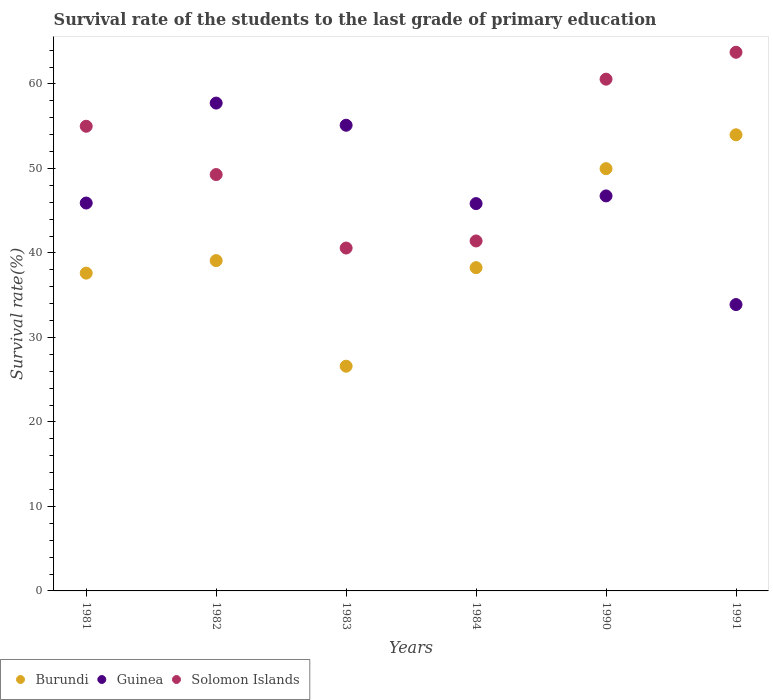Is the number of dotlines equal to the number of legend labels?
Give a very brief answer. Yes. What is the survival rate of the students in Guinea in 1982?
Keep it short and to the point. 57.73. Across all years, what is the maximum survival rate of the students in Burundi?
Offer a very short reply. 53.98. Across all years, what is the minimum survival rate of the students in Burundi?
Ensure brevity in your answer.  26.59. In which year was the survival rate of the students in Guinea minimum?
Offer a very short reply. 1991. What is the total survival rate of the students in Guinea in the graph?
Provide a short and direct response. 285.21. What is the difference between the survival rate of the students in Guinea in 1982 and that in 1991?
Your answer should be very brief. 23.84. What is the difference between the survival rate of the students in Solomon Islands in 1984 and the survival rate of the students in Burundi in 1982?
Your response must be concise. 2.32. What is the average survival rate of the students in Solomon Islands per year?
Your answer should be very brief. 51.76. In the year 1984, what is the difference between the survival rate of the students in Burundi and survival rate of the students in Solomon Islands?
Make the answer very short. -3.16. In how many years, is the survival rate of the students in Burundi greater than 26 %?
Provide a succinct answer. 6. What is the ratio of the survival rate of the students in Solomon Islands in 1982 to that in 1991?
Provide a short and direct response. 0.77. Is the difference between the survival rate of the students in Burundi in 1983 and 1991 greater than the difference between the survival rate of the students in Solomon Islands in 1983 and 1991?
Your response must be concise. No. What is the difference between the highest and the second highest survival rate of the students in Solomon Islands?
Keep it short and to the point. 3.18. What is the difference between the highest and the lowest survival rate of the students in Burundi?
Make the answer very short. 27.39. In how many years, is the survival rate of the students in Solomon Islands greater than the average survival rate of the students in Solomon Islands taken over all years?
Ensure brevity in your answer.  3. Is the sum of the survival rate of the students in Guinea in 1984 and 1990 greater than the maximum survival rate of the students in Solomon Islands across all years?
Offer a terse response. Yes. Is the survival rate of the students in Burundi strictly greater than the survival rate of the students in Solomon Islands over the years?
Ensure brevity in your answer.  No. How many dotlines are there?
Offer a very short reply. 3. How many years are there in the graph?
Keep it short and to the point. 6. Are the values on the major ticks of Y-axis written in scientific E-notation?
Offer a very short reply. No. How are the legend labels stacked?
Offer a terse response. Horizontal. What is the title of the graph?
Give a very brief answer. Survival rate of the students to the last grade of primary education. What is the label or title of the X-axis?
Give a very brief answer. Years. What is the label or title of the Y-axis?
Your answer should be compact. Survival rate(%). What is the Survival rate(%) in Burundi in 1981?
Offer a very short reply. 37.61. What is the Survival rate(%) of Guinea in 1981?
Make the answer very short. 45.9. What is the Survival rate(%) of Solomon Islands in 1981?
Make the answer very short. 54.99. What is the Survival rate(%) in Burundi in 1982?
Give a very brief answer. 39.09. What is the Survival rate(%) in Guinea in 1982?
Your answer should be compact. 57.73. What is the Survival rate(%) of Solomon Islands in 1982?
Your answer should be compact. 49.27. What is the Survival rate(%) of Burundi in 1983?
Your response must be concise. 26.59. What is the Survival rate(%) of Guinea in 1983?
Your answer should be very brief. 55.11. What is the Survival rate(%) in Solomon Islands in 1983?
Offer a terse response. 40.58. What is the Survival rate(%) of Burundi in 1984?
Provide a succinct answer. 38.26. What is the Survival rate(%) in Guinea in 1984?
Make the answer very short. 45.84. What is the Survival rate(%) of Solomon Islands in 1984?
Your response must be concise. 41.41. What is the Survival rate(%) in Burundi in 1990?
Offer a very short reply. 49.97. What is the Survival rate(%) of Guinea in 1990?
Provide a short and direct response. 46.75. What is the Survival rate(%) of Solomon Islands in 1990?
Your answer should be very brief. 60.56. What is the Survival rate(%) of Burundi in 1991?
Your response must be concise. 53.98. What is the Survival rate(%) of Guinea in 1991?
Make the answer very short. 33.89. What is the Survival rate(%) of Solomon Islands in 1991?
Provide a succinct answer. 63.74. Across all years, what is the maximum Survival rate(%) of Burundi?
Ensure brevity in your answer.  53.98. Across all years, what is the maximum Survival rate(%) of Guinea?
Your answer should be compact. 57.73. Across all years, what is the maximum Survival rate(%) of Solomon Islands?
Your response must be concise. 63.74. Across all years, what is the minimum Survival rate(%) of Burundi?
Keep it short and to the point. 26.59. Across all years, what is the minimum Survival rate(%) in Guinea?
Keep it short and to the point. 33.89. Across all years, what is the minimum Survival rate(%) in Solomon Islands?
Your answer should be compact. 40.58. What is the total Survival rate(%) in Burundi in the graph?
Offer a terse response. 245.5. What is the total Survival rate(%) of Guinea in the graph?
Ensure brevity in your answer.  285.21. What is the total Survival rate(%) in Solomon Islands in the graph?
Your response must be concise. 310.56. What is the difference between the Survival rate(%) of Burundi in 1981 and that in 1982?
Give a very brief answer. -1.48. What is the difference between the Survival rate(%) of Guinea in 1981 and that in 1982?
Offer a very short reply. -11.83. What is the difference between the Survival rate(%) of Solomon Islands in 1981 and that in 1982?
Ensure brevity in your answer.  5.72. What is the difference between the Survival rate(%) of Burundi in 1981 and that in 1983?
Offer a very short reply. 11.01. What is the difference between the Survival rate(%) in Guinea in 1981 and that in 1983?
Offer a very short reply. -9.21. What is the difference between the Survival rate(%) of Solomon Islands in 1981 and that in 1983?
Provide a succinct answer. 14.41. What is the difference between the Survival rate(%) in Burundi in 1981 and that in 1984?
Provide a succinct answer. -0.65. What is the difference between the Survival rate(%) of Guinea in 1981 and that in 1984?
Offer a terse response. 0.07. What is the difference between the Survival rate(%) in Solomon Islands in 1981 and that in 1984?
Make the answer very short. 13.58. What is the difference between the Survival rate(%) in Burundi in 1981 and that in 1990?
Give a very brief answer. -12.37. What is the difference between the Survival rate(%) in Guinea in 1981 and that in 1990?
Ensure brevity in your answer.  -0.84. What is the difference between the Survival rate(%) of Solomon Islands in 1981 and that in 1990?
Make the answer very short. -5.57. What is the difference between the Survival rate(%) of Burundi in 1981 and that in 1991?
Your answer should be very brief. -16.37. What is the difference between the Survival rate(%) of Guinea in 1981 and that in 1991?
Ensure brevity in your answer.  12.02. What is the difference between the Survival rate(%) of Solomon Islands in 1981 and that in 1991?
Provide a short and direct response. -8.76. What is the difference between the Survival rate(%) of Burundi in 1982 and that in 1983?
Offer a terse response. 12.5. What is the difference between the Survival rate(%) in Guinea in 1982 and that in 1983?
Keep it short and to the point. 2.62. What is the difference between the Survival rate(%) of Solomon Islands in 1982 and that in 1983?
Your answer should be very brief. 8.7. What is the difference between the Survival rate(%) in Burundi in 1982 and that in 1984?
Make the answer very short. 0.83. What is the difference between the Survival rate(%) of Guinea in 1982 and that in 1984?
Your answer should be very brief. 11.89. What is the difference between the Survival rate(%) of Solomon Islands in 1982 and that in 1984?
Offer a very short reply. 7.86. What is the difference between the Survival rate(%) of Burundi in 1982 and that in 1990?
Your answer should be very brief. -10.88. What is the difference between the Survival rate(%) of Guinea in 1982 and that in 1990?
Your response must be concise. 10.99. What is the difference between the Survival rate(%) of Solomon Islands in 1982 and that in 1990?
Offer a terse response. -11.29. What is the difference between the Survival rate(%) of Burundi in 1982 and that in 1991?
Provide a succinct answer. -14.89. What is the difference between the Survival rate(%) in Guinea in 1982 and that in 1991?
Give a very brief answer. 23.84. What is the difference between the Survival rate(%) in Solomon Islands in 1982 and that in 1991?
Ensure brevity in your answer.  -14.47. What is the difference between the Survival rate(%) of Burundi in 1983 and that in 1984?
Your answer should be compact. -11.66. What is the difference between the Survival rate(%) of Guinea in 1983 and that in 1984?
Your answer should be very brief. 9.27. What is the difference between the Survival rate(%) of Solomon Islands in 1983 and that in 1984?
Provide a succinct answer. -0.84. What is the difference between the Survival rate(%) of Burundi in 1983 and that in 1990?
Provide a succinct answer. -23.38. What is the difference between the Survival rate(%) of Guinea in 1983 and that in 1990?
Keep it short and to the point. 8.36. What is the difference between the Survival rate(%) of Solomon Islands in 1983 and that in 1990?
Give a very brief answer. -19.98. What is the difference between the Survival rate(%) of Burundi in 1983 and that in 1991?
Ensure brevity in your answer.  -27.39. What is the difference between the Survival rate(%) in Guinea in 1983 and that in 1991?
Offer a terse response. 21.22. What is the difference between the Survival rate(%) in Solomon Islands in 1983 and that in 1991?
Make the answer very short. -23.17. What is the difference between the Survival rate(%) in Burundi in 1984 and that in 1990?
Make the answer very short. -11.72. What is the difference between the Survival rate(%) of Guinea in 1984 and that in 1990?
Offer a terse response. -0.91. What is the difference between the Survival rate(%) in Solomon Islands in 1984 and that in 1990?
Provide a short and direct response. -19.15. What is the difference between the Survival rate(%) in Burundi in 1984 and that in 1991?
Offer a terse response. -15.72. What is the difference between the Survival rate(%) in Guinea in 1984 and that in 1991?
Keep it short and to the point. 11.95. What is the difference between the Survival rate(%) of Solomon Islands in 1984 and that in 1991?
Offer a terse response. -22.33. What is the difference between the Survival rate(%) of Burundi in 1990 and that in 1991?
Offer a very short reply. -4.01. What is the difference between the Survival rate(%) of Guinea in 1990 and that in 1991?
Offer a very short reply. 12.86. What is the difference between the Survival rate(%) of Solomon Islands in 1990 and that in 1991?
Make the answer very short. -3.18. What is the difference between the Survival rate(%) in Burundi in 1981 and the Survival rate(%) in Guinea in 1982?
Ensure brevity in your answer.  -20.12. What is the difference between the Survival rate(%) in Burundi in 1981 and the Survival rate(%) in Solomon Islands in 1982?
Provide a short and direct response. -11.67. What is the difference between the Survival rate(%) of Guinea in 1981 and the Survival rate(%) of Solomon Islands in 1982?
Keep it short and to the point. -3.37. What is the difference between the Survival rate(%) in Burundi in 1981 and the Survival rate(%) in Guinea in 1983?
Keep it short and to the point. -17.5. What is the difference between the Survival rate(%) in Burundi in 1981 and the Survival rate(%) in Solomon Islands in 1983?
Your answer should be compact. -2.97. What is the difference between the Survival rate(%) of Guinea in 1981 and the Survival rate(%) of Solomon Islands in 1983?
Provide a short and direct response. 5.33. What is the difference between the Survival rate(%) of Burundi in 1981 and the Survival rate(%) of Guinea in 1984?
Make the answer very short. -8.23. What is the difference between the Survival rate(%) in Burundi in 1981 and the Survival rate(%) in Solomon Islands in 1984?
Give a very brief answer. -3.81. What is the difference between the Survival rate(%) in Guinea in 1981 and the Survival rate(%) in Solomon Islands in 1984?
Provide a succinct answer. 4.49. What is the difference between the Survival rate(%) of Burundi in 1981 and the Survival rate(%) of Guinea in 1990?
Give a very brief answer. -9.14. What is the difference between the Survival rate(%) in Burundi in 1981 and the Survival rate(%) in Solomon Islands in 1990?
Give a very brief answer. -22.95. What is the difference between the Survival rate(%) of Guinea in 1981 and the Survival rate(%) of Solomon Islands in 1990?
Give a very brief answer. -14.66. What is the difference between the Survival rate(%) of Burundi in 1981 and the Survival rate(%) of Guinea in 1991?
Give a very brief answer. 3.72. What is the difference between the Survival rate(%) in Burundi in 1981 and the Survival rate(%) in Solomon Islands in 1991?
Your answer should be compact. -26.14. What is the difference between the Survival rate(%) of Guinea in 1981 and the Survival rate(%) of Solomon Islands in 1991?
Offer a very short reply. -17.84. What is the difference between the Survival rate(%) of Burundi in 1982 and the Survival rate(%) of Guinea in 1983?
Provide a succinct answer. -16.02. What is the difference between the Survival rate(%) of Burundi in 1982 and the Survival rate(%) of Solomon Islands in 1983?
Offer a terse response. -1.49. What is the difference between the Survival rate(%) in Guinea in 1982 and the Survival rate(%) in Solomon Islands in 1983?
Your answer should be very brief. 17.15. What is the difference between the Survival rate(%) of Burundi in 1982 and the Survival rate(%) of Guinea in 1984?
Offer a terse response. -6.75. What is the difference between the Survival rate(%) in Burundi in 1982 and the Survival rate(%) in Solomon Islands in 1984?
Your response must be concise. -2.32. What is the difference between the Survival rate(%) in Guinea in 1982 and the Survival rate(%) in Solomon Islands in 1984?
Offer a very short reply. 16.32. What is the difference between the Survival rate(%) in Burundi in 1982 and the Survival rate(%) in Guinea in 1990?
Your answer should be compact. -7.65. What is the difference between the Survival rate(%) in Burundi in 1982 and the Survival rate(%) in Solomon Islands in 1990?
Ensure brevity in your answer.  -21.47. What is the difference between the Survival rate(%) in Guinea in 1982 and the Survival rate(%) in Solomon Islands in 1990?
Your answer should be compact. -2.83. What is the difference between the Survival rate(%) of Burundi in 1982 and the Survival rate(%) of Guinea in 1991?
Keep it short and to the point. 5.2. What is the difference between the Survival rate(%) of Burundi in 1982 and the Survival rate(%) of Solomon Islands in 1991?
Your response must be concise. -24.65. What is the difference between the Survival rate(%) of Guinea in 1982 and the Survival rate(%) of Solomon Islands in 1991?
Give a very brief answer. -6.01. What is the difference between the Survival rate(%) of Burundi in 1983 and the Survival rate(%) of Guinea in 1984?
Your response must be concise. -19.24. What is the difference between the Survival rate(%) in Burundi in 1983 and the Survival rate(%) in Solomon Islands in 1984?
Provide a succinct answer. -14.82. What is the difference between the Survival rate(%) of Guinea in 1983 and the Survival rate(%) of Solomon Islands in 1984?
Your response must be concise. 13.69. What is the difference between the Survival rate(%) in Burundi in 1983 and the Survival rate(%) in Guinea in 1990?
Provide a short and direct response. -20.15. What is the difference between the Survival rate(%) in Burundi in 1983 and the Survival rate(%) in Solomon Islands in 1990?
Your response must be concise. -33.97. What is the difference between the Survival rate(%) of Guinea in 1983 and the Survival rate(%) of Solomon Islands in 1990?
Your response must be concise. -5.45. What is the difference between the Survival rate(%) of Burundi in 1983 and the Survival rate(%) of Guinea in 1991?
Keep it short and to the point. -7.29. What is the difference between the Survival rate(%) in Burundi in 1983 and the Survival rate(%) in Solomon Islands in 1991?
Your answer should be very brief. -37.15. What is the difference between the Survival rate(%) of Guinea in 1983 and the Survival rate(%) of Solomon Islands in 1991?
Ensure brevity in your answer.  -8.64. What is the difference between the Survival rate(%) of Burundi in 1984 and the Survival rate(%) of Guinea in 1990?
Ensure brevity in your answer.  -8.49. What is the difference between the Survival rate(%) in Burundi in 1984 and the Survival rate(%) in Solomon Islands in 1990?
Make the answer very short. -22.31. What is the difference between the Survival rate(%) in Guinea in 1984 and the Survival rate(%) in Solomon Islands in 1990?
Make the answer very short. -14.72. What is the difference between the Survival rate(%) in Burundi in 1984 and the Survival rate(%) in Guinea in 1991?
Ensure brevity in your answer.  4.37. What is the difference between the Survival rate(%) of Burundi in 1984 and the Survival rate(%) of Solomon Islands in 1991?
Provide a short and direct response. -25.49. What is the difference between the Survival rate(%) in Guinea in 1984 and the Survival rate(%) in Solomon Islands in 1991?
Ensure brevity in your answer.  -17.91. What is the difference between the Survival rate(%) of Burundi in 1990 and the Survival rate(%) of Guinea in 1991?
Give a very brief answer. 16.09. What is the difference between the Survival rate(%) of Burundi in 1990 and the Survival rate(%) of Solomon Islands in 1991?
Provide a short and direct response. -13.77. What is the difference between the Survival rate(%) of Guinea in 1990 and the Survival rate(%) of Solomon Islands in 1991?
Your answer should be very brief. -17. What is the average Survival rate(%) in Burundi per year?
Ensure brevity in your answer.  40.92. What is the average Survival rate(%) in Guinea per year?
Your response must be concise. 47.54. What is the average Survival rate(%) of Solomon Islands per year?
Make the answer very short. 51.76. In the year 1981, what is the difference between the Survival rate(%) of Burundi and Survival rate(%) of Guinea?
Keep it short and to the point. -8.3. In the year 1981, what is the difference between the Survival rate(%) in Burundi and Survival rate(%) in Solomon Islands?
Your answer should be very brief. -17.38. In the year 1981, what is the difference between the Survival rate(%) in Guinea and Survival rate(%) in Solomon Islands?
Provide a short and direct response. -9.09. In the year 1982, what is the difference between the Survival rate(%) of Burundi and Survival rate(%) of Guinea?
Make the answer very short. -18.64. In the year 1982, what is the difference between the Survival rate(%) in Burundi and Survival rate(%) in Solomon Islands?
Give a very brief answer. -10.18. In the year 1982, what is the difference between the Survival rate(%) in Guinea and Survival rate(%) in Solomon Islands?
Your answer should be very brief. 8.46. In the year 1983, what is the difference between the Survival rate(%) of Burundi and Survival rate(%) of Guinea?
Ensure brevity in your answer.  -28.51. In the year 1983, what is the difference between the Survival rate(%) of Burundi and Survival rate(%) of Solomon Islands?
Provide a short and direct response. -13.98. In the year 1983, what is the difference between the Survival rate(%) in Guinea and Survival rate(%) in Solomon Islands?
Make the answer very short. 14.53. In the year 1984, what is the difference between the Survival rate(%) of Burundi and Survival rate(%) of Guinea?
Your answer should be compact. -7.58. In the year 1984, what is the difference between the Survival rate(%) of Burundi and Survival rate(%) of Solomon Islands?
Provide a succinct answer. -3.16. In the year 1984, what is the difference between the Survival rate(%) in Guinea and Survival rate(%) in Solomon Islands?
Your response must be concise. 4.42. In the year 1990, what is the difference between the Survival rate(%) in Burundi and Survival rate(%) in Guinea?
Your answer should be very brief. 3.23. In the year 1990, what is the difference between the Survival rate(%) in Burundi and Survival rate(%) in Solomon Islands?
Offer a very short reply. -10.59. In the year 1990, what is the difference between the Survival rate(%) of Guinea and Survival rate(%) of Solomon Islands?
Your answer should be very brief. -13.82. In the year 1991, what is the difference between the Survival rate(%) of Burundi and Survival rate(%) of Guinea?
Ensure brevity in your answer.  20.09. In the year 1991, what is the difference between the Survival rate(%) in Burundi and Survival rate(%) in Solomon Islands?
Provide a short and direct response. -9.77. In the year 1991, what is the difference between the Survival rate(%) of Guinea and Survival rate(%) of Solomon Islands?
Make the answer very short. -29.86. What is the ratio of the Survival rate(%) in Burundi in 1981 to that in 1982?
Provide a short and direct response. 0.96. What is the ratio of the Survival rate(%) in Guinea in 1981 to that in 1982?
Ensure brevity in your answer.  0.8. What is the ratio of the Survival rate(%) in Solomon Islands in 1981 to that in 1982?
Ensure brevity in your answer.  1.12. What is the ratio of the Survival rate(%) in Burundi in 1981 to that in 1983?
Your response must be concise. 1.41. What is the ratio of the Survival rate(%) in Guinea in 1981 to that in 1983?
Offer a very short reply. 0.83. What is the ratio of the Survival rate(%) in Solomon Islands in 1981 to that in 1983?
Provide a succinct answer. 1.36. What is the ratio of the Survival rate(%) in Burundi in 1981 to that in 1984?
Provide a short and direct response. 0.98. What is the ratio of the Survival rate(%) of Guinea in 1981 to that in 1984?
Offer a terse response. 1. What is the ratio of the Survival rate(%) of Solomon Islands in 1981 to that in 1984?
Give a very brief answer. 1.33. What is the ratio of the Survival rate(%) of Burundi in 1981 to that in 1990?
Offer a terse response. 0.75. What is the ratio of the Survival rate(%) in Guinea in 1981 to that in 1990?
Give a very brief answer. 0.98. What is the ratio of the Survival rate(%) in Solomon Islands in 1981 to that in 1990?
Provide a succinct answer. 0.91. What is the ratio of the Survival rate(%) in Burundi in 1981 to that in 1991?
Your answer should be very brief. 0.7. What is the ratio of the Survival rate(%) of Guinea in 1981 to that in 1991?
Your answer should be compact. 1.35. What is the ratio of the Survival rate(%) in Solomon Islands in 1981 to that in 1991?
Ensure brevity in your answer.  0.86. What is the ratio of the Survival rate(%) of Burundi in 1982 to that in 1983?
Your response must be concise. 1.47. What is the ratio of the Survival rate(%) in Guinea in 1982 to that in 1983?
Provide a succinct answer. 1.05. What is the ratio of the Survival rate(%) in Solomon Islands in 1982 to that in 1983?
Keep it short and to the point. 1.21. What is the ratio of the Survival rate(%) in Burundi in 1982 to that in 1984?
Offer a terse response. 1.02. What is the ratio of the Survival rate(%) in Guinea in 1982 to that in 1984?
Your answer should be very brief. 1.26. What is the ratio of the Survival rate(%) in Solomon Islands in 1982 to that in 1984?
Provide a short and direct response. 1.19. What is the ratio of the Survival rate(%) in Burundi in 1982 to that in 1990?
Offer a terse response. 0.78. What is the ratio of the Survival rate(%) of Guinea in 1982 to that in 1990?
Your response must be concise. 1.24. What is the ratio of the Survival rate(%) in Solomon Islands in 1982 to that in 1990?
Provide a short and direct response. 0.81. What is the ratio of the Survival rate(%) of Burundi in 1982 to that in 1991?
Provide a short and direct response. 0.72. What is the ratio of the Survival rate(%) in Guinea in 1982 to that in 1991?
Offer a very short reply. 1.7. What is the ratio of the Survival rate(%) of Solomon Islands in 1982 to that in 1991?
Offer a very short reply. 0.77. What is the ratio of the Survival rate(%) in Burundi in 1983 to that in 1984?
Keep it short and to the point. 0.7. What is the ratio of the Survival rate(%) of Guinea in 1983 to that in 1984?
Provide a short and direct response. 1.2. What is the ratio of the Survival rate(%) in Solomon Islands in 1983 to that in 1984?
Provide a succinct answer. 0.98. What is the ratio of the Survival rate(%) of Burundi in 1983 to that in 1990?
Your answer should be compact. 0.53. What is the ratio of the Survival rate(%) of Guinea in 1983 to that in 1990?
Make the answer very short. 1.18. What is the ratio of the Survival rate(%) in Solomon Islands in 1983 to that in 1990?
Provide a succinct answer. 0.67. What is the ratio of the Survival rate(%) of Burundi in 1983 to that in 1991?
Provide a short and direct response. 0.49. What is the ratio of the Survival rate(%) of Guinea in 1983 to that in 1991?
Keep it short and to the point. 1.63. What is the ratio of the Survival rate(%) of Solomon Islands in 1983 to that in 1991?
Offer a very short reply. 0.64. What is the ratio of the Survival rate(%) in Burundi in 1984 to that in 1990?
Your answer should be compact. 0.77. What is the ratio of the Survival rate(%) of Guinea in 1984 to that in 1990?
Give a very brief answer. 0.98. What is the ratio of the Survival rate(%) of Solomon Islands in 1984 to that in 1990?
Offer a terse response. 0.68. What is the ratio of the Survival rate(%) in Burundi in 1984 to that in 1991?
Provide a short and direct response. 0.71. What is the ratio of the Survival rate(%) in Guinea in 1984 to that in 1991?
Provide a short and direct response. 1.35. What is the ratio of the Survival rate(%) of Solomon Islands in 1984 to that in 1991?
Your answer should be very brief. 0.65. What is the ratio of the Survival rate(%) of Burundi in 1990 to that in 1991?
Offer a terse response. 0.93. What is the ratio of the Survival rate(%) of Guinea in 1990 to that in 1991?
Your answer should be compact. 1.38. What is the ratio of the Survival rate(%) of Solomon Islands in 1990 to that in 1991?
Provide a succinct answer. 0.95. What is the difference between the highest and the second highest Survival rate(%) in Burundi?
Provide a succinct answer. 4.01. What is the difference between the highest and the second highest Survival rate(%) of Guinea?
Ensure brevity in your answer.  2.62. What is the difference between the highest and the second highest Survival rate(%) in Solomon Islands?
Ensure brevity in your answer.  3.18. What is the difference between the highest and the lowest Survival rate(%) in Burundi?
Your answer should be compact. 27.39. What is the difference between the highest and the lowest Survival rate(%) of Guinea?
Your response must be concise. 23.84. What is the difference between the highest and the lowest Survival rate(%) in Solomon Islands?
Make the answer very short. 23.17. 